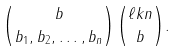Convert formula to latex. <formula><loc_0><loc_0><loc_500><loc_500>\binom { b } { b _ { 1 } , b _ { 2 } , \dots , b _ { n } } \binom { \ell k n } { b } .</formula> 